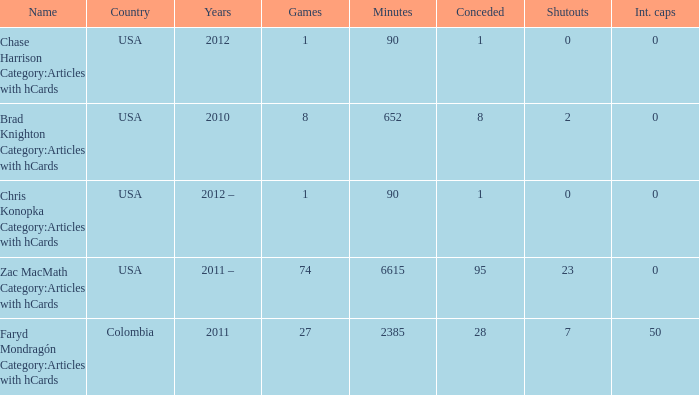What is the least overall number of shutouts? 0.0. Would you be able to parse every entry in this table? {'header': ['Name', 'Country', 'Years', 'Games', 'Minutes', 'Conceded', 'Shutouts', 'Int. caps'], 'rows': [['Chase Harrison Category:Articles with hCards', 'USA', '2012', '1', '90', '1', '0', '0'], ['Brad Knighton Category:Articles with hCards', 'USA', '2010', '8', '652', '8', '2', '0'], ['Chris Konopka Category:Articles with hCards', 'USA', '2012 –', '1', '90', '1', '0', '0'], ['Zac MacMath Category:Articles with hCards', 'USA', '2011 –', '74', '6615', '95', '23', '0'], ['Faryd Mondragón Category:Articles with hCards', 'Colombia', '2011', '27', '2385', '28', '7', '50']]} 